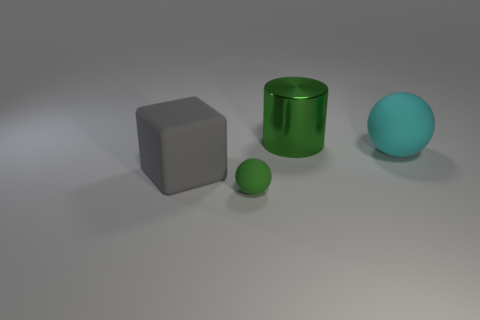Add 4 big gray objects. How many objects exist? 8 Subtract all cylinders. How many objects are left? 3 Subtract 0 purple balls. How many objects are left? 4 Subtract all tiny spheres. Subtract all large shiny cylinders. How many objects are left? 2 Add 2 big gray rubber blocks. How many big gray rubber blocks are left? 3 Add 1 yellow matte balls. How many yellow matte balls exist? 1 